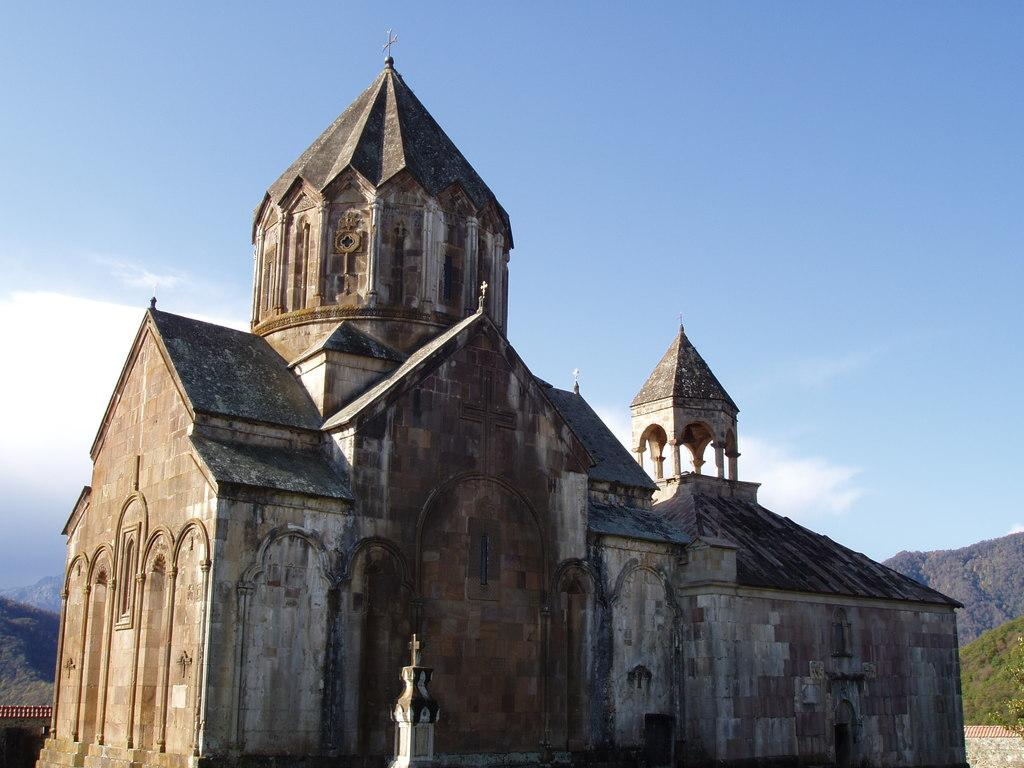What type of structure is present in the image? There is a building in the image. What can be seen at the bottom left side of the image? There are hills at the bottom left side of the image. What is present at the bottom right side of the image? There are hills at the bottom right side of the image. What is visible in the background of the image? The sky is visible in the background of the image. What type of haircut does the building have in the image? The building does not have a haircut, as it is a structure and not a living being. 